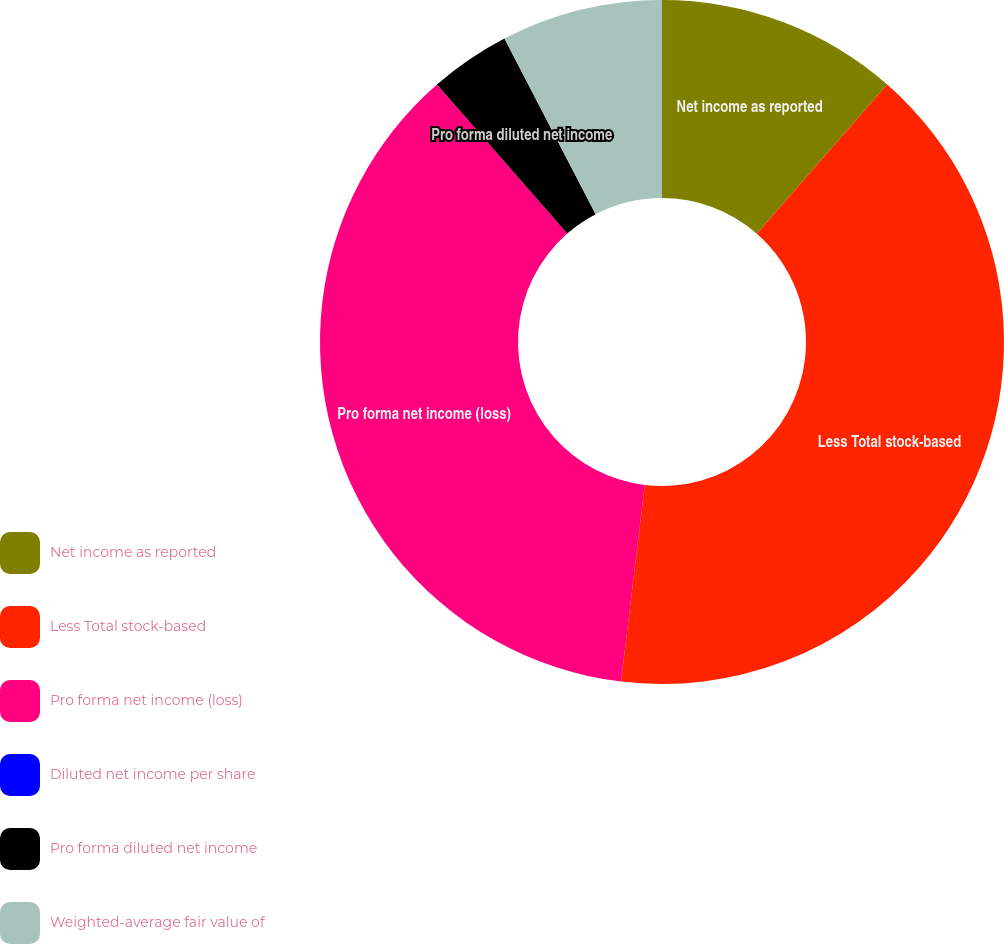<chart> <loc_0><loc_0><loc_500><loc_500><pie_chart><fcel>Net income as reported<fcel>Less Total stock-based<fcel>Pro forma net income (loss)<fcel>Diluted net income per share<fcel>Pro forma diluted net income<fcel>Weighted-average fair value of<nl><fcel>11.44%<fcel>40.47%<fcel>36.66%<fcel>0.0%<fcel>3.81%<fcel>7.62%<nl></chart> 